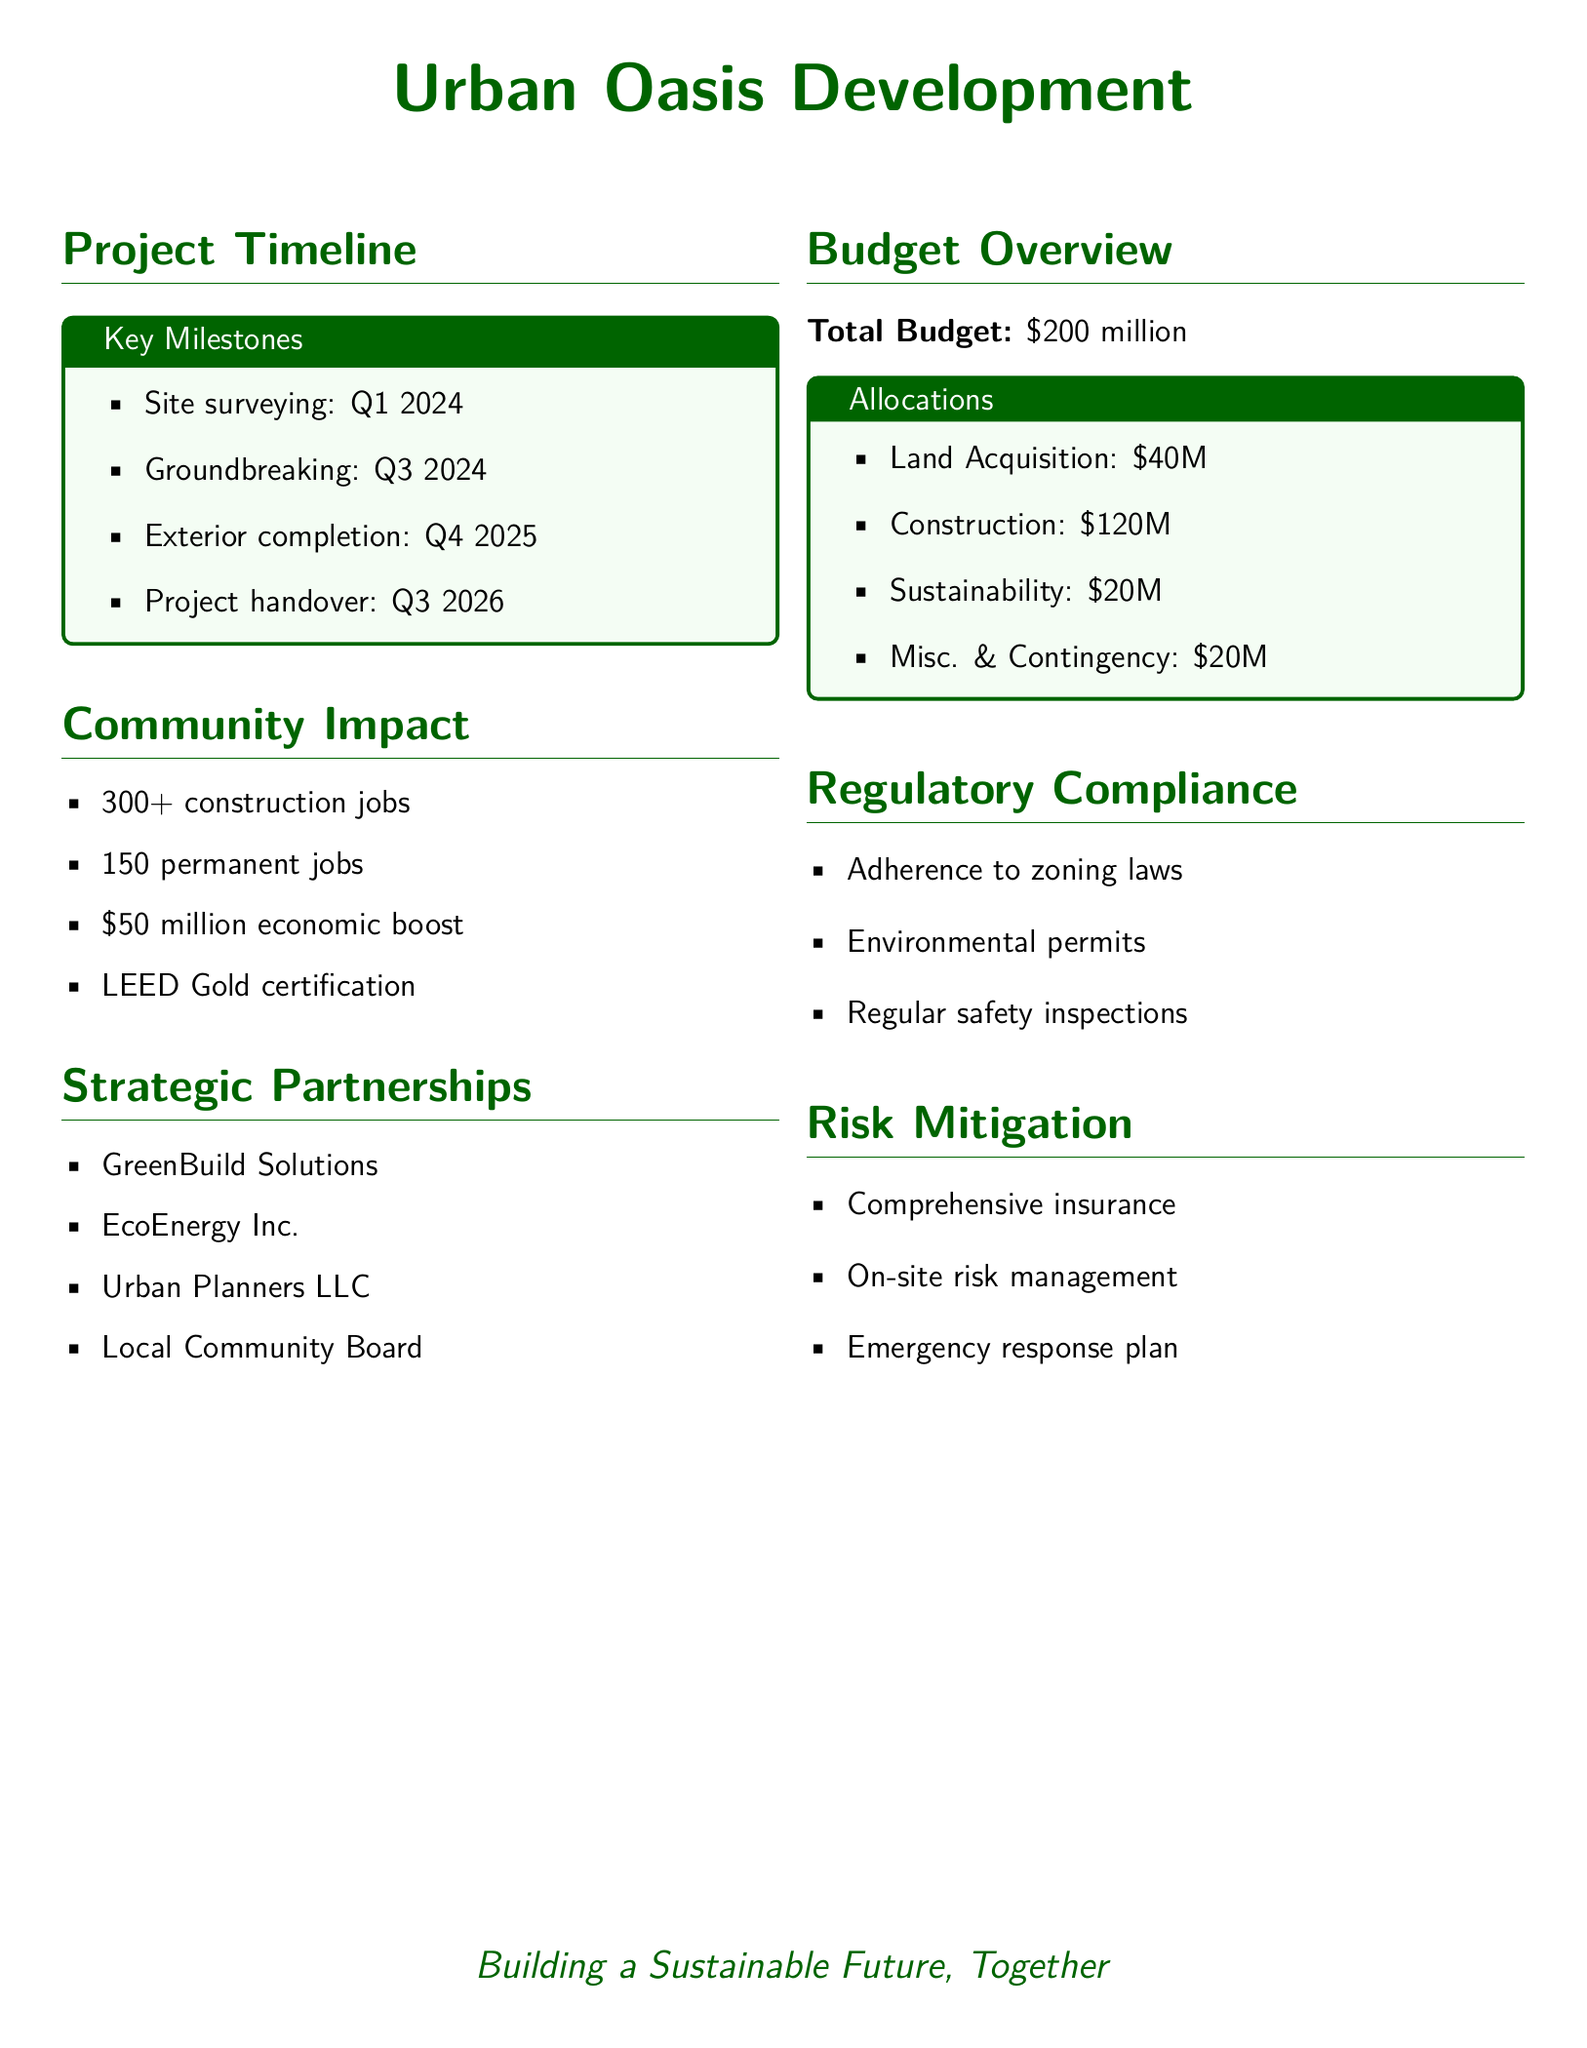What is the total budget? The total budget is listed in the document as $200 million.
Answer: $200 million When is the groundbreaking scheduled? The document states that groundbreaking is scheduled for Q3 2024.
Answer: Q3 2024 How many permanent jobs will the project create? According to the community impact section, the project will create 150 permanent jobs.
Answer: 150 permanent jobs What is one certification goal for the project? The document indicates that the project aims for LEED Gold certification.
Answer: LEED Gold certification Who is one of the strategic partners? The document lists several partners, one of which is GreenBuild Solutions.
Answer: GreenBuild Solutions What is the total allocated budget for sustainability? The document specifies that $20 million is allocated for sustainability.
Answer: $20 million How many construction jobs will the project create? The community impact report states that there will be over 300 construction jobs.
Answer: 300+ construction jobs What is one regulatory compliance measure mentioned? The document mentions adherence to zoning laws as a compliance measure.
Answer: Adherence to zoning laws What is the projected economic boost from the project? According to the community impact section, the project is projected to provide a $50 million economic boost.
Answer: $50 million 